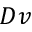Convert formula to latex. <formula><loc_0><loc_0><loc_500><loc_500>D v</formula> 